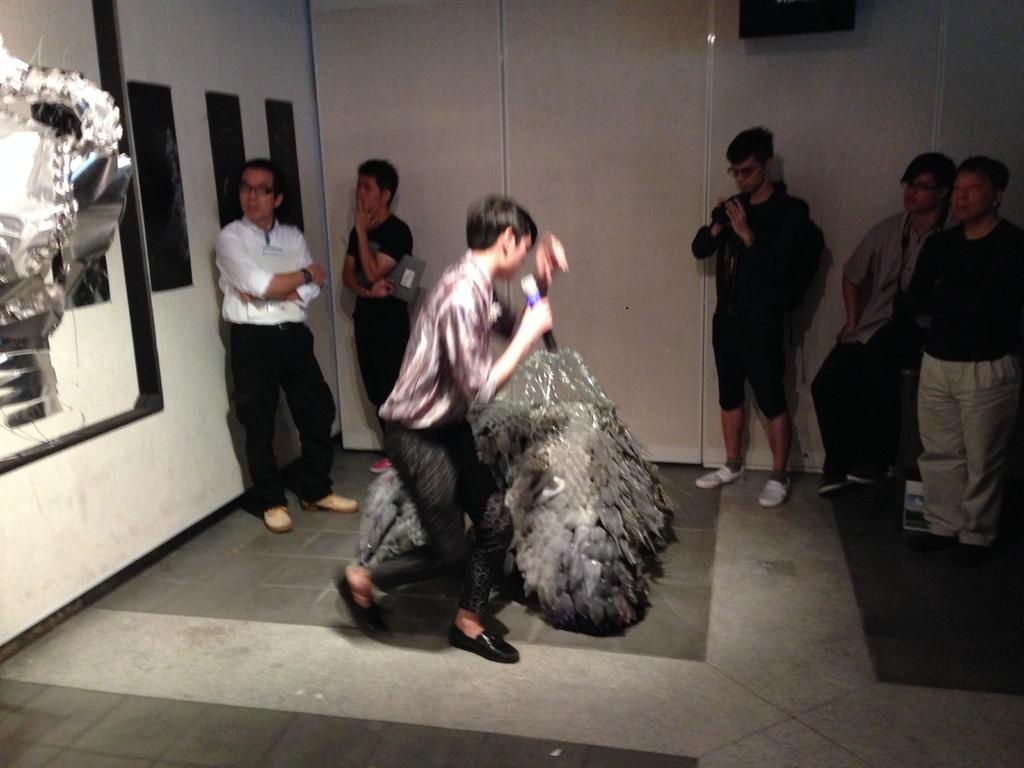Please provide a concise description of this image. In the center of the image, we can see a creature and in the background, there are people and some are holding objects and there is a wall and we can see a statue. At the bottom, there is a floor. 